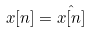<formula> <loc_0><loc_0><loc_500><loc_500>x [ n ] = \hat { x [ n ] }</formula> 